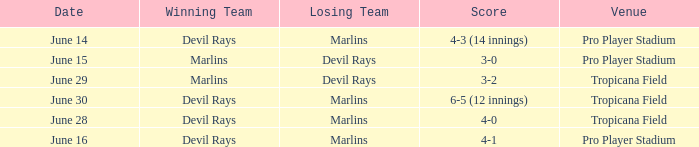What was the score on june 29? 3-2. 